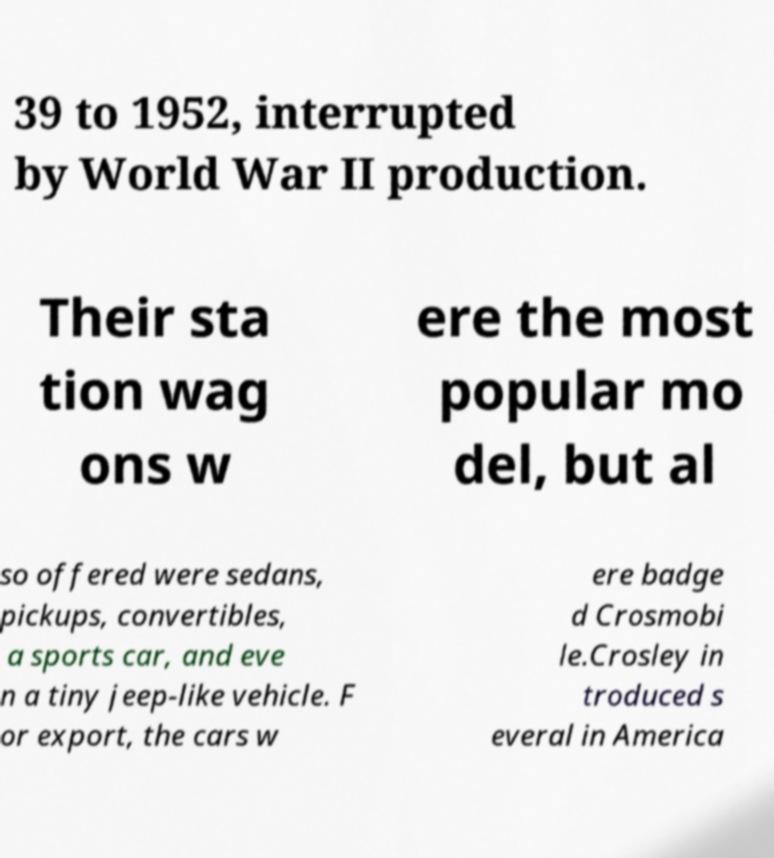I need the written content from this picture converted into text. Can you do that? 39 to 1952, interrupted by World War II production. Their sta tion wag ons w ere the most popular mo del, but al so offered were sedans, pickups, convertibles, a sports car, and eve n a tiny jeep-like vehicle. F or export, the cars w ere badge d Crosmobi le.Crosley in troduced s everal in America 